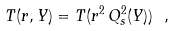<formula> <loc_0><loc_0><loc_500><loc_500>T ( r , Y ) = T ( r ^ { 2 } \, Q ^ { 2 } _ { s } ( Y ) ) \ ,</formula> 